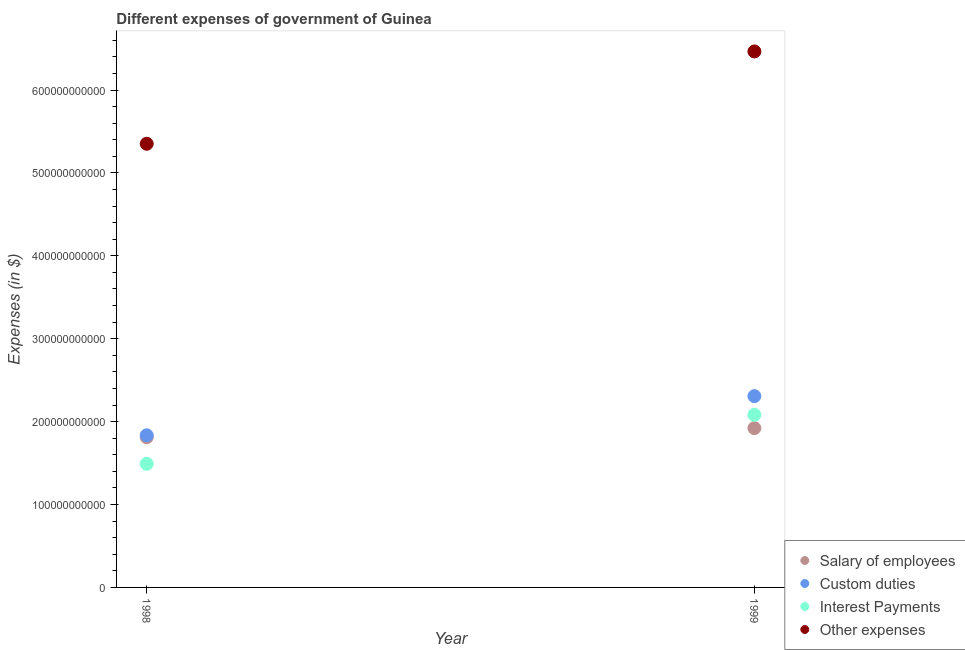What is the amount spent on interest payments in 1998?
Your answer should be compact. 1.49e+11. Across all years, what is the maximum amount spent on other expenses?
Your response must be concise. 6.47e+11. Across all years, what is the minimum amount spent on salary of employees?
Your answer should be compact. 1.81e+11. What is the total amount spent on interest payments in the graph?
Your answer should be very brief. 3.57e+11. What is the difference between the amount spent on custom duties in 1998 and that in 1999?
Your response must be concise. -4.72e+1. What is the difference between the amount spent on salary of employees in 1999 and the amount spent on custom duties in 1998?
Your answer should be compact. 8.67e+09. What is the average amount spent on custom duties per year?
Your answer should be very brief. 2.07e+11. In the year 1998, what is the difference between the amount spent on custom duties and amount spent on other expenses?
Make the answer very short. -3.52e+11. In how many years, is the amount spent on salary of employees greater than 220000000000 $?
Provide a succinct answer. 0. What is the ratio of the amount spent on other expenses in 1998 to that in 1999?
Offer a terse response. 0.83. In how many years, is the amount spent on other expenses greater than the average amount spent on other expenses taken over all years?
Offer a very short reply. 1. Is it the case that in every year, the sum of the amount spent on salary of employees and amount spent on other expenses is greater than the sum of amount spent on custom duties and amount spent on interest payments?
Make the answer very short. Yes. Does the amount spent on salary of employees monotonically increase over the years?
Give a very brief answer. Yes. How many years are there in the graph?
Your response must be concise. 2. What is the difference between two consecutive major ticks on the Y-axis?
Offer a terse response. 1.00e+11. Are the values on the major ticks of Y-axis written in scientific E-notation?
Your answer should be very brief. No. Does the graph contain grids?
Provide a succinct answer. No. How many legend labels are there?
Provide a succinct answer. 4. How are the legend labels stacked?
Keep it short and to the point. Vertical. What is the title of the graph?
Offer a terse response. Different expenses of government of Guinea. What is the label or title of the X-axis?
Provide a succinct answer. Year. What is the label or title of the Y-axis?
Make the answer very short. Expenses (in $). What is the Expenses (in $) in Salary of employees in 1998?
Keep it short and to the point. 1.81e+11. What is the Expenses (in $) in Custom duties in 1998?
Your response must be concise. 1.84e+11. What is the Expenses (in $) of Interest Payments in 1998?
Make the answer very short. 1.49e+11. What is the Expenses (in $) in Other expenses in 1998?
Your answer should be very brief. 5.35e+11. What is the Expenses (in $) of Salary of employees in 1999?
Your response must be concise. 1.92e+11. What is the Expenses (in $) in Custom duties in 1999?
Give a very brief answer. 2.31e+11. What is the Expenses (in $) in Interest Payments in 1999?
Provide a succinct answer. 2.08e+11. What is the Expenses (in $) of Other expenses in 1999?
Provide a short and direct response. 6.47e+11. Across all years, what is the maximum Expenses (in $) of Salary of employees?
Your answer should be very brief. 1.92e+11. Across all years, what is the maximum Expenses (in $) in Custom duties?
Your response must be concise. 2.31e+11. Across all years, what is the maximum Expenses (in $) in Interest Payments?
Your answer should be compact. 2.08e+11. Across all years, what is the maximum Expenses (in $) in Other expenses?
Offer a very short reply. 6.47e+11. Across all years, what is the minimum Expenses (in $) of Salary of employees?
Make the answer very short. 1.81e+11. Across all years, what is the minimum Expenses (in $) of Custom duties?
Your answer should be compact. 1.84e+11. Across all years, what is the minimum Expenses (in $) of Interest Payments?
Make the answer very short. 1.49e+11. Across all years, what is the minimum Expenses (in $) in Other expenses?
Your answer should be compact. 5.35e+11. What is the total Expenses (in $) in Salary of employees in the graph?
Your answer should be very brief. 3.73e+11. What is the total Expenses (in $) in Custom duties in the graph?
Offer a very short reply. 4.14e+11. What is the total Expenses (in $) in Interest Payments in the graph?
Provide a short and direct response. 3.57e+11. What is the total Expenses (in $) in Other expenses in the graph?
Your answer should be very brief. 1.18e+12. What is the difference between the Expenses (in $) of Salary of employees in 1998 and that in 1999?
Offer a terse response. -1.10e+1. What is the difference between the Expenses (in $) of Custom duties in 1998 and that in 1999?
Your answer should be very brief. -4.72e+1. What is the difference between the Expenses (in $) in Interest Payments in 1998 and that in 1999?
Ensure brevity in your answer.  -5.90e+1. What is the difference between the Expenses (in $) of Other expenses in 1998 and that in 1999?
Your response must be concise. -1.11e+11. What is the difference between the Expenses (in $) of Salary of employees in 1998 and the Expenses (in $) of Custom duties in 1999?
Ensure brevity in your answer.  -4.96e+1. What is the difference between the Expenses (in $) of Salary of employees in 1998 and the Expenses (in $) of Interest Payments in 1999?
Provide a succinct answer. -2.69e+1. What is the difference between the Expenses (in $) of Salary of employees in 1998 and the Expenses (in $) of Other expenses in 1999?
Your answer should be compact. -4.65e+11. What is the difference between the Expenses (in $) of Custom duties in 1998 and the Expenses (in $) of Interest Payments in 1999?
Your answer should be compact. -2.46e+1. What is the difference between the Expenses (in $) in Custom duties in 1998 and the Expenses (in $) in Other expenses in 1999?
Provide a short and direct response. -4.63e+11. What is the difference between the Expenses (in $) in Interest Payments in 1998 and the Expenses (in $) in Other expenses in 1999?
Your answer should be very brief. -4.97e+11. What is the average Expenses (in $) in Salary of employees per year?
Your answer should be compact. 1.87e+11. What is the average Expenses (in $) in Custom duties per year?
Offer a very short reply. 2.07e+11. What is the average Expenses (in $) in Interest Payments per year?
Provide a succinct answer. 1.79e+11. What is the average Expenses (in $) of Other expenses per year?
Your response must be concise. 5.91e+11. In the year 1998, what is the difference between the Expenses (in $) in Salary of employees and Expenses (in $) in Custom duties?
Provide a short and direct response. -2.33e+09. In the year 1998, what is the difference between the Expenses (in $) of Salary of employees and Expenses (in $) of Interest Payments?
Ensure brevity in your answer.  3.21e+1. In the year 1998, what is the difference between the Expenses (in $) of Salary of employees and Expenses (in $) of Other expenses?
Your answer should be very brief. -3.54e+11. In the year 1998, what is the difference between the Expenses (in $) of Custom duties and Expenses (in $) of Interest Payments?
Your response must be concise. 3.44e+1. In the year 1998, what is the difference between the Expenses (in $) of Custom duties and Expenses (in $) of Other expenses?
Your answer should be compact. -3.52e+11. In the year 1998, what is the difference between the Expenses (in $) in Interest Payments and Expenses (in $) in Other expenses?
Give a very brief answer. -3.86e+11. In the year 1999, what is the difference between the Expenses (in $) of Salary of employees and Expenses (in $) of Custom duties?
Provide a short and direct response. -3.86e+1. In the year 1999, what is the difference between the Expenses (in $) of Salary of employees and Expenses (in $) of Interest Payments?
Ensure brevity in your answer.  -1.60e+1. In the year 1999, what is the difference between the Expenses (in $) of Salary of employees and Expenses (in $) of Other expenses?
Provide a succinct answer. -4.54e+11. In the year 1999, what is the difference between the Expenses (in $) in Custom duties and Expenses (in $) in Interest Payments?
Offer a very short reply. 2.26e+1. In the year 1999, what is the difference between the Expenses (in $) in Custom duties and Expenses (in $) in Other expenses?
Your answer should be very brief. -4.16e+11. In the year 1999, what is the difference between the Expenses (in $) in Interest Payments and Expenses (in $) in Other expenses?
Offer a terse response. -4.38e+11. What is the ratio of the Expenses (in $) in Salary of employees in 1998 to that in 1999?
Provide a short and direct response. 0.94. What is the ratio of the Expenses (in $) of Custom duties in 1998 to that in 1999?
Offer a very short reply. 0.8. What is the ratio of the Expenses (in $) in Interest Payments in 1998 to that in 1999?
Offer a very short reply. 0.72. What is the ratio of the Expenses (in $) in Other expenses in 1998 to that in 1999?
Give a very brief answer. 0.83. What is the difference between the highest and the second highest Expenses (in $) in Salary of employees?
Ensure brevity in your answer.  1.10e+1. What is the difference between the highest and the second highest Expenses (in $) in Custom duties?
Offer a terse response. 4.72e+1. What is the difference between the highest and the second highest Expenses (in $) of Interest Payments?
Offer a very short reply. 5.90e+1. What is the difference between the highest and the second highest Expenses (in $) in Other expenses?
Ensure brevity in your answer.  1.11e+11. What is the difference between the highest and the lowest Expenses (in $) of Salary of employees?
Ensure brevity in your answer.  1.10e+1. What is the difference between the highest and the lowest Expenses (in $) in Custom duties?
Your answer should be very brief. 4.72e+1. What is the difference between the highest and the lowest Expenses (in $) of Interest Payments?
Make the answer very short. 5.90e+1. What is the difference between the highest and the lowest Expenses (in $) of Other expenses?
Provide a succinct answer. 1.11e+11. 